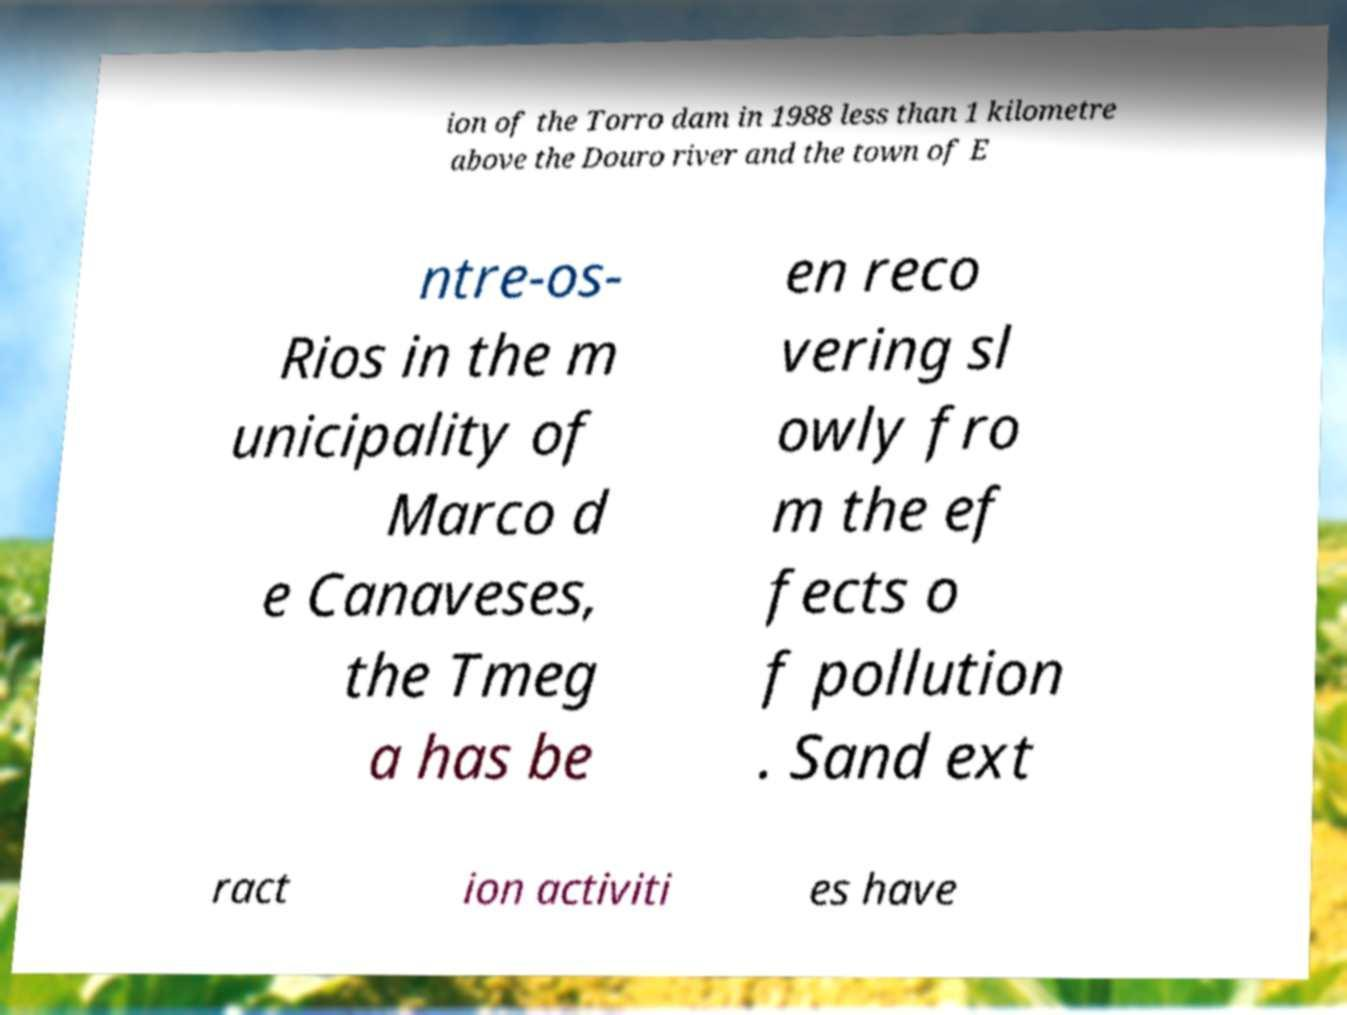Could you extract and type out the text from this image? ion of the Torro dam in 1988 less than 1 kilometre above the Douro river and the town of E ntre-os- Rios in the m unicipality of Marco d e Canaveses, the Tmeg a has be en reco vering sl owly fro m the ef fects o f pollution . Sand ext ract ion activiti es have 